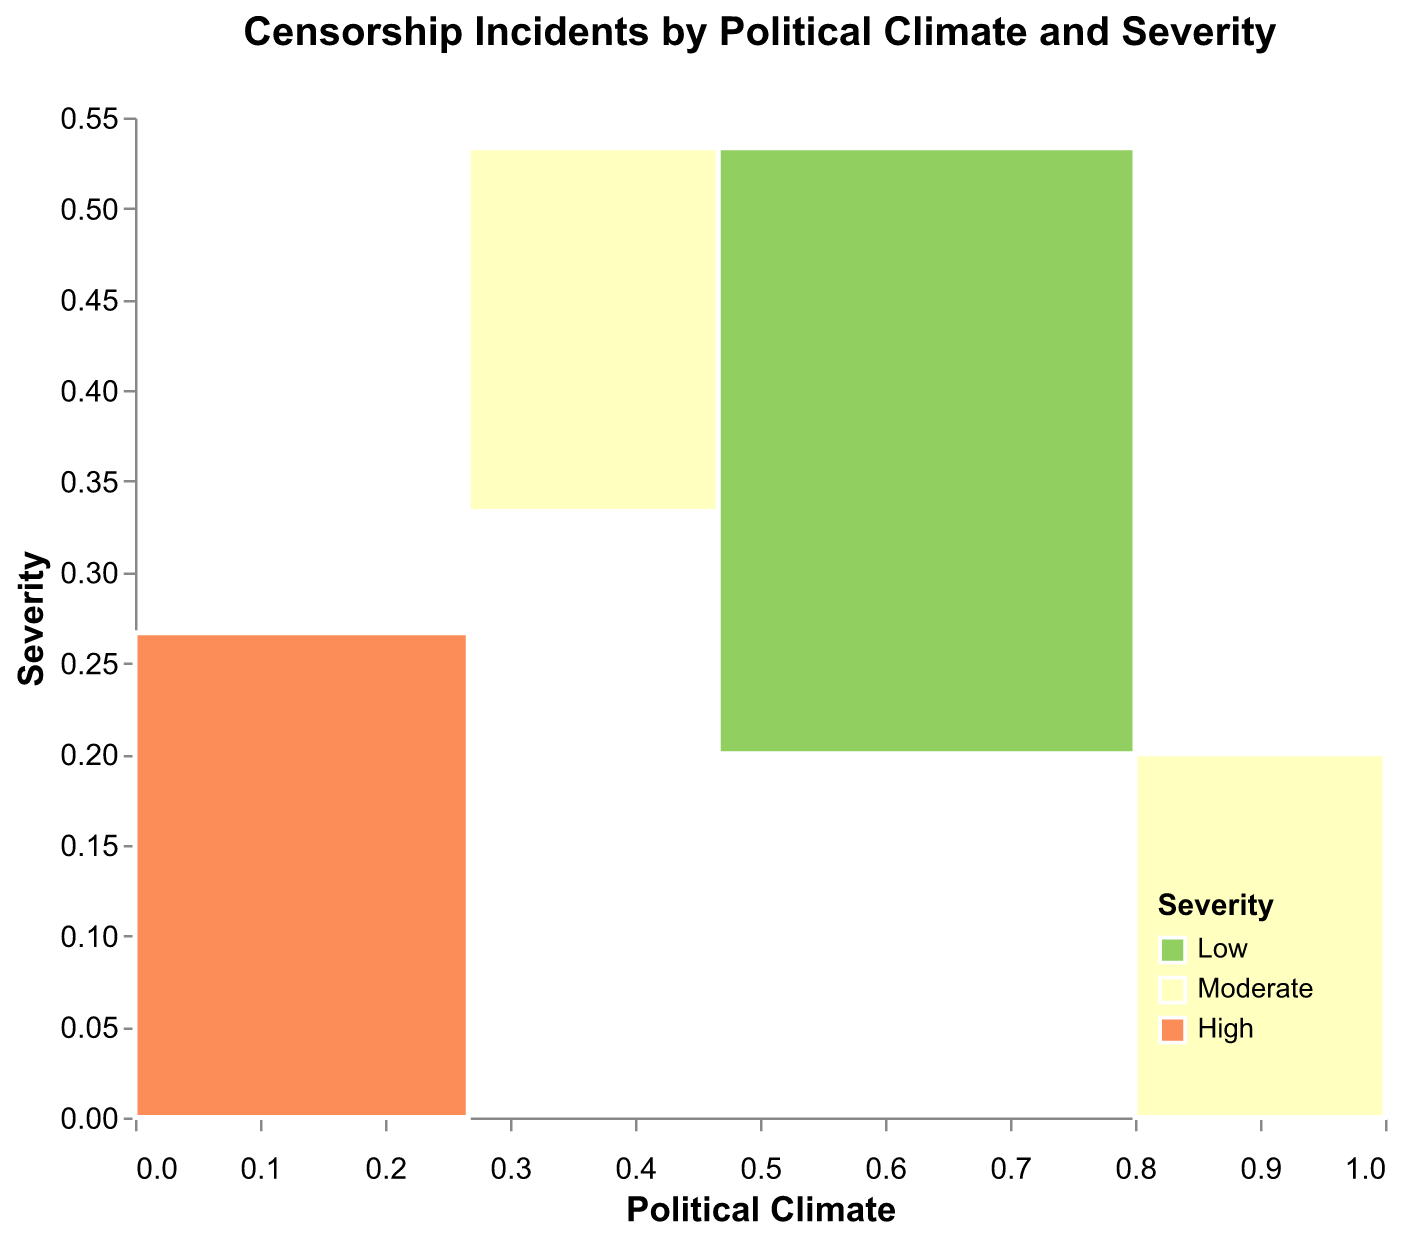How many political climates are represented in the figure? The x-axis represents political climates, and there are three distinct segments shown.
Answer: 3 What does the color red represent in the plot? The legend at the bottom-right indicates that red corresponds to high severity.
Answer: High severity Which political climate has the highest number of high severity censorship incidents? By inspecting the area with the color red, the authoritarian climate occupies the largest red portion.
Answer: Authoritarian How do the censorship incidents in Democratic climates compare between moderate and low severity? For Democratic climates, the areas of moderate (yellow) and low severity (green) can be compared. Moderates occupy a larger portion.
Answer: Moderate is greater Which country has the highest count of censorship incidents? The tooltip information reveals this detail. China, with 22 incidents, has the largest number.
Answer: China Compare the total number of censorship incidents between Authoritarian and Democratic climates. Summing up incidents for Authoritarian: 15 (Russia) + 22 (China) + 18 (Iran) + 20 (Saudi Arabia) = 75. For Democratic: 7 (US) + 3 (UK) + 2 (Germany) + 4 (France) + 1 (Japan) + 2 (Australia) + 5 (Brazil) + 6 (Poland) = 30.
Answer: Authoritarian is greater Which political climate category has the least number of low severity incidents? By looking at the small green sections in the plot, Democratic and Hybrid Regimes both have small areas, but Democratic has slightly more countries in green.
Answer: Hybrid Regime What is the total count of moderate severity incidents across all political climates? Democratic: 7 + 5 + 6 = 18, Hybrid Regime: 11 + 9 + 8 = 28. Summing these gives 18 + 28 = 46.
Answer: 46 Are there more censorship incidents in Hybrid Regimes or Democratic climates? Summing the Hybrid regimes' censorship incidents: 11 (Egypt) + 9 (Turkey) + 8 (Hungary) = 28. Summing Democratic incidents: 7 + 3 + 2 + 4 + 1 + 2 + 5 + 6 = 30.
Answer: Democratic is greater 